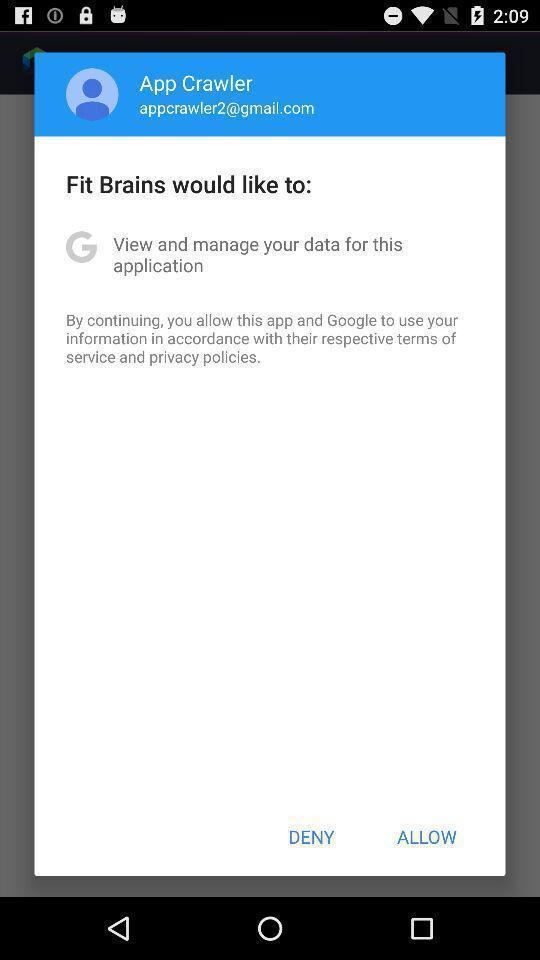Describe this image in words. Pop-up showing a notification to allow. 